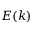Convert formula to latex. <formula><loc_0><loc_0><loc_500><loc_500>E ( k )</formula> 